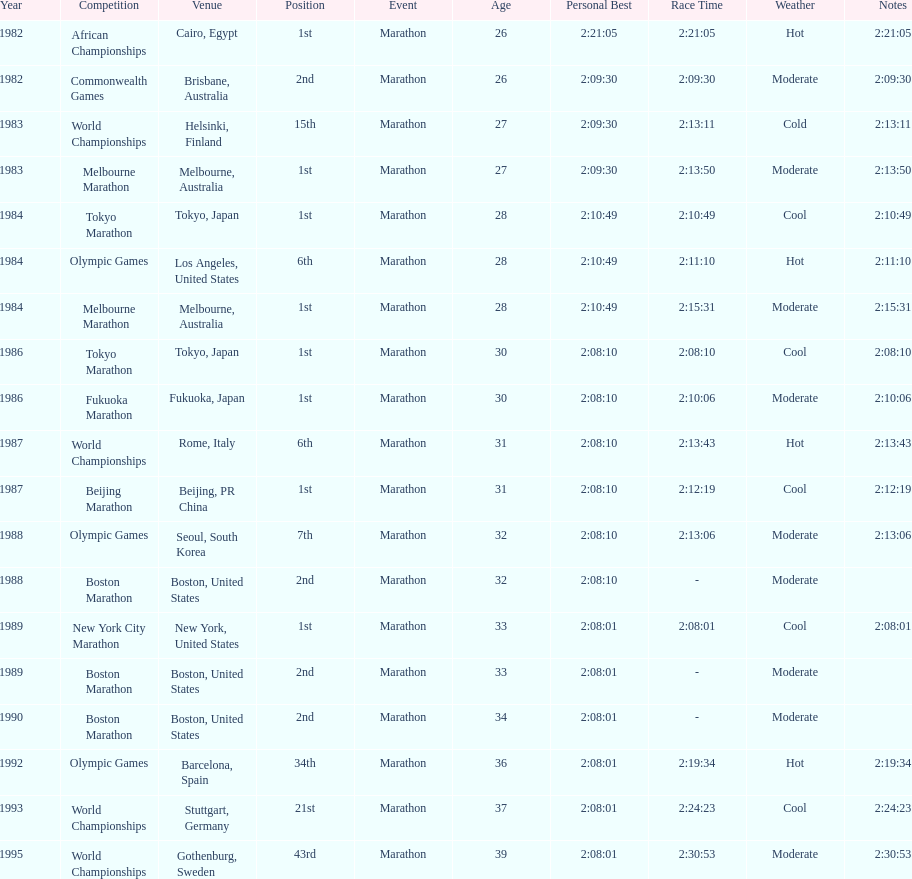What were the number of times the venue was located in the united states? 5. 